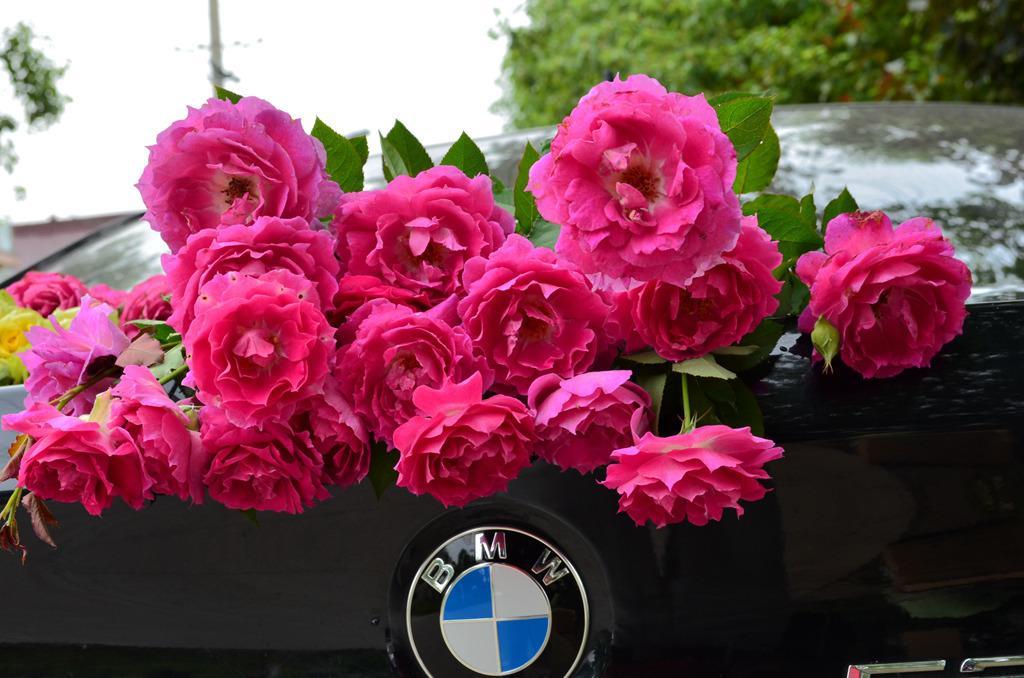Please provide a concise description of this image. In this image, I can see a bunch of rose flowers, which are pink in color. These are the leaves. I think these flowers are kept on a vehicle. This is a logo, which is attached to the vehicle. In the background, I can see the trees. 